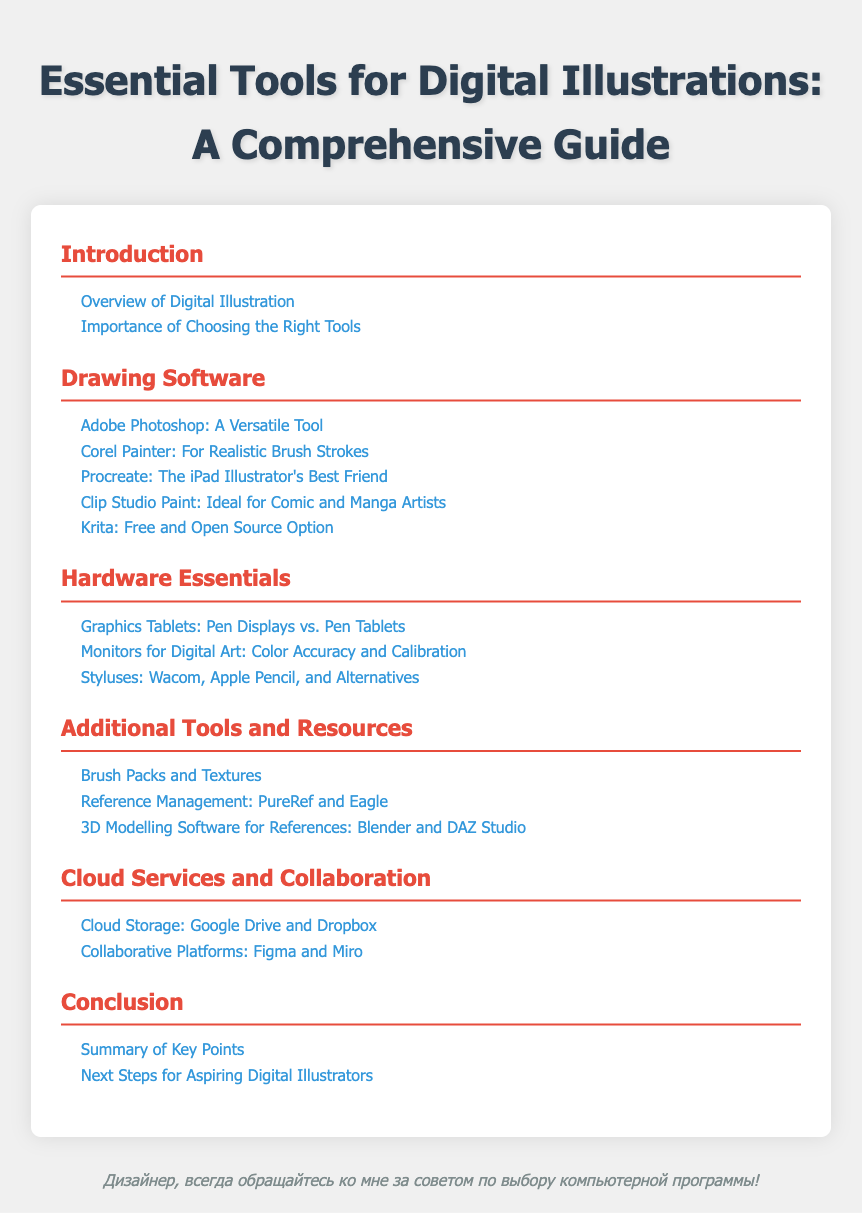what is the first section in the table of contents? The first section listed in the table of contents is "Introduction."
Answer: Introduction how many drawing software tools are listed? The document lists a total of five drawing software tools.
Answer: 5 which tool is highlighted as the best friend for iPad illustrators? "Procreate" is mentioned as the iPad illustrator's best friend.
Answer: Procreate what is the focus of the section on hardware essentials? The hardware essentials section focuses on tools like graphics tablets, monitors, and styluses.
Answer: Graphics Tablets, Monitors, Styluses what is the purpose of the "Additional Tools and Resources" section? This section provides information on supplementary resources such as brush packs, reference management, and 3D modeling software.
Answer: Supplementary resources how many subsections are under 'Cloud Services and Collaboration'? There are two subsections under 'Cloud Services and Collaboration.'
Answer: 2 what is mentioned as an alternative for styluses? The document states "and Alternatives" in reference to styluses, implying there are other options.
Answer: Alternatives which cloud storage services are mentioned? "Google Drive and Dropbox" are the cloud storage services referred to in the document.
Answer: Google Drive and Dropbox what section summarizes the key points? The section that summarizes the key points is titled "Conclusion."
Answer: Conclusion 